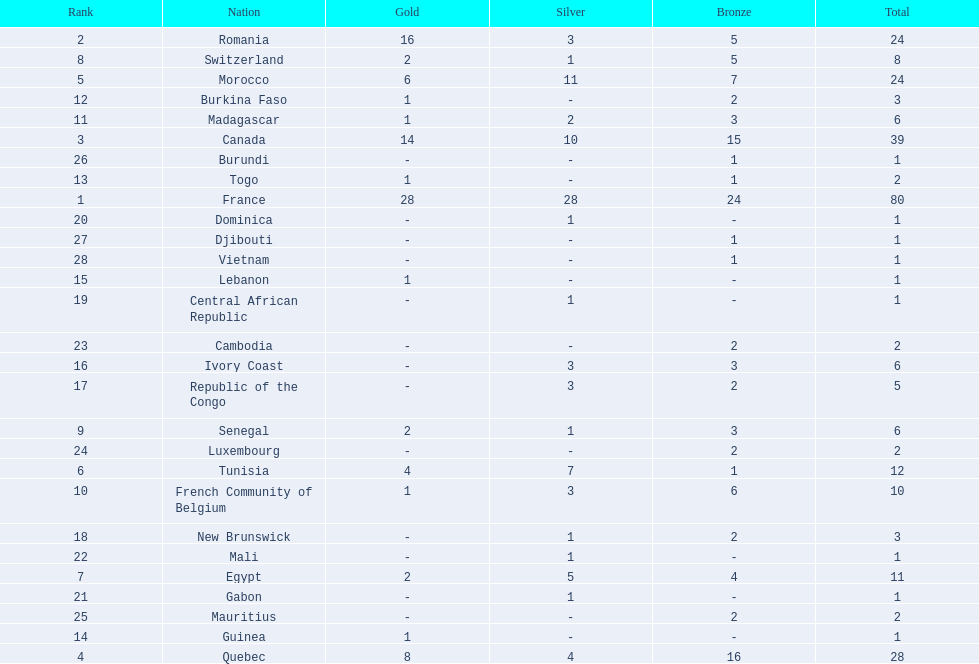What was the total medal count of switzerland? 8. 